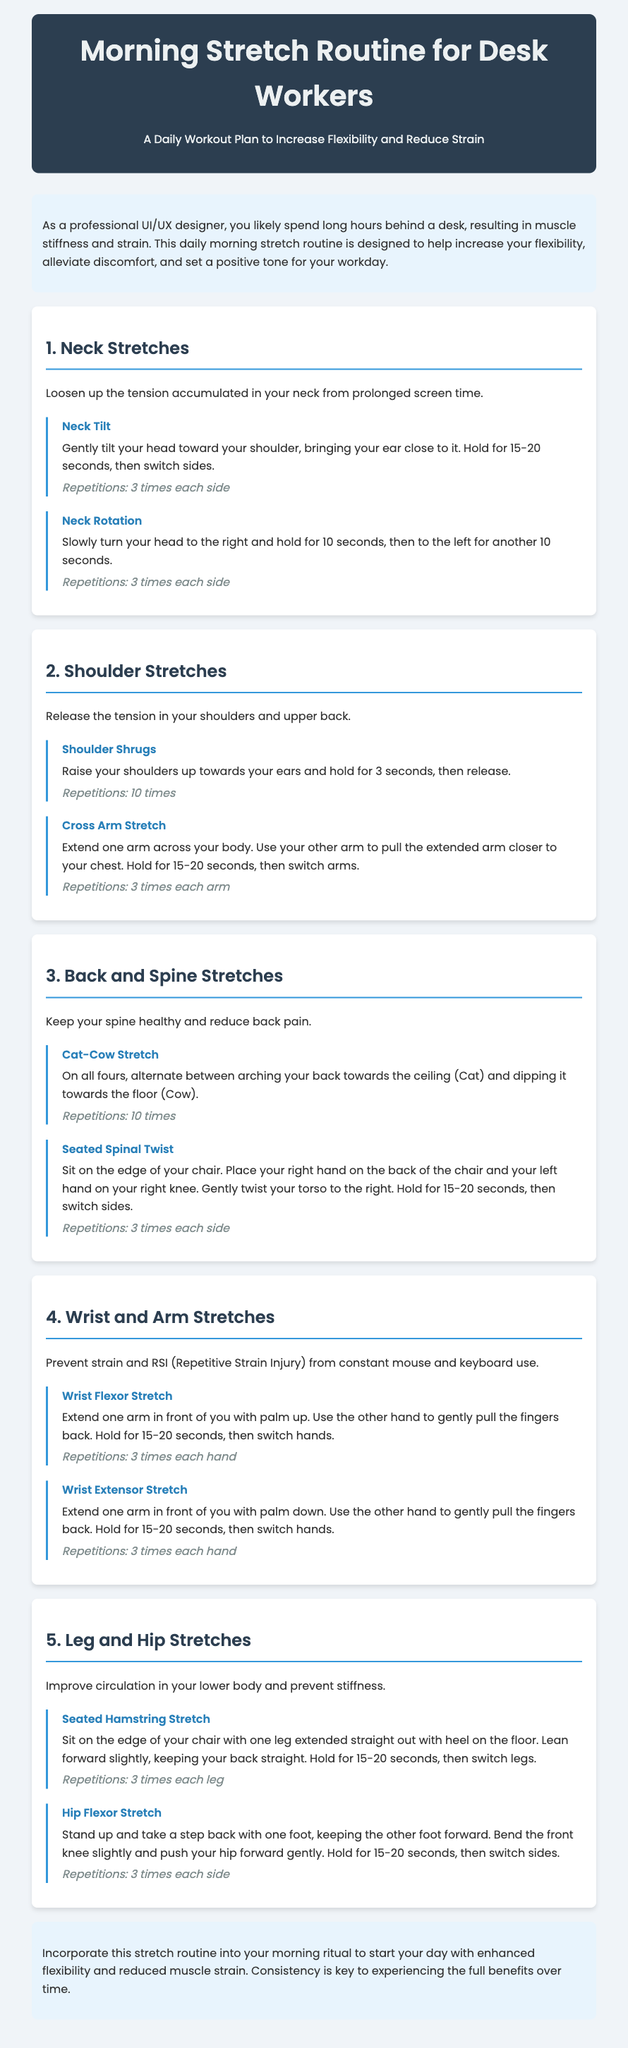What is the title of the document? The title of the document is the main heading at the top.
Answer: Morning Stretch Routine for Desk Workers How many repetitions are recommended for the Neck Tilt exercise? The repetitions for the Neck Tilt exercise are specified under the exercise description.
Answer: 3 times each side What are the two stretches mentioned under Shoulder Stretches? The stretches are listed as exercises in the section about Shoulder Stretches.
Answer: Shoulder Shrugs, Cross Arm Stretch What is the purpose of the Wrist Flexor Stretch? The purpose is mentioned in the section heading focusing on wrist and arm health.
Answer: Prevent strain and RSI How long should you hold each stretch? The hold duration for most stretches is specified in the descriptions.
Answer: 15-20 seconds 